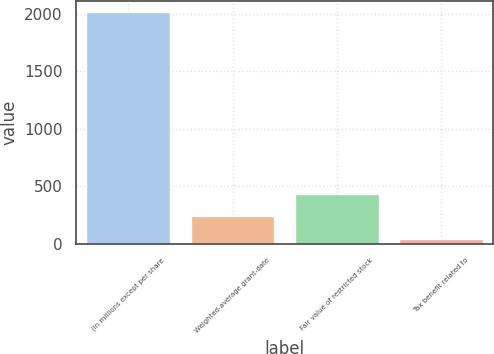Convert chart to OTSL. <chart><loc_0><loc_0><loc_500><loc_500><bar_chart><fcel>(in millions except per share<fcel>Weighted-average grant-date<fcel>Fair value of restricted stock<fcel>Tax benefit related to<nl><fcel>2014<fcel>237.4<fcel>434.8<fcel>40<nl></chart> 